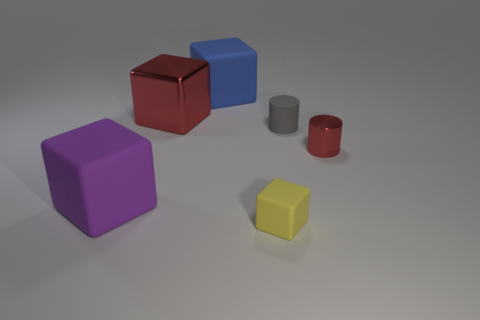How many balls are either cyan shiny things or purple things?
Offer a terse response. 0. There is a red metal cube to the left of the red thing that is to the right of the tiny yellow rubber thing; what is its size?
Provide a short and direct response. Large. There is a tiny rubber cylinder; is it the same color as the big rubber thing behind the tiny gray rubber cylinder?
Keep it short and to the point. No. What number of matte blocks are to the left of the big red thing?
Your answer should be very brief. 1. Are there fewer large gray metallic objects than tiny red shiny objects?
Make the answer very short. Yes. What is the size of the thing that is to the right of the large red metallic block and behind the tiny gray rubber thing?
Keep it short and to the point. Large. Is the color of the big block that is behind the large red metal thing the same as the tiny matte cube?
Ensure brevity in your answer.  No. Is the number of blue objects in front of the purple block less than the number of cylinders?
Make the answer very short. Yes. What is the shape of the tiny object that is the same material as the big red thing?
Offer a terse response. Cylinder. Is the material of the large blue thing the same as the big purple object?
Your answer should be very brief. Yes. 